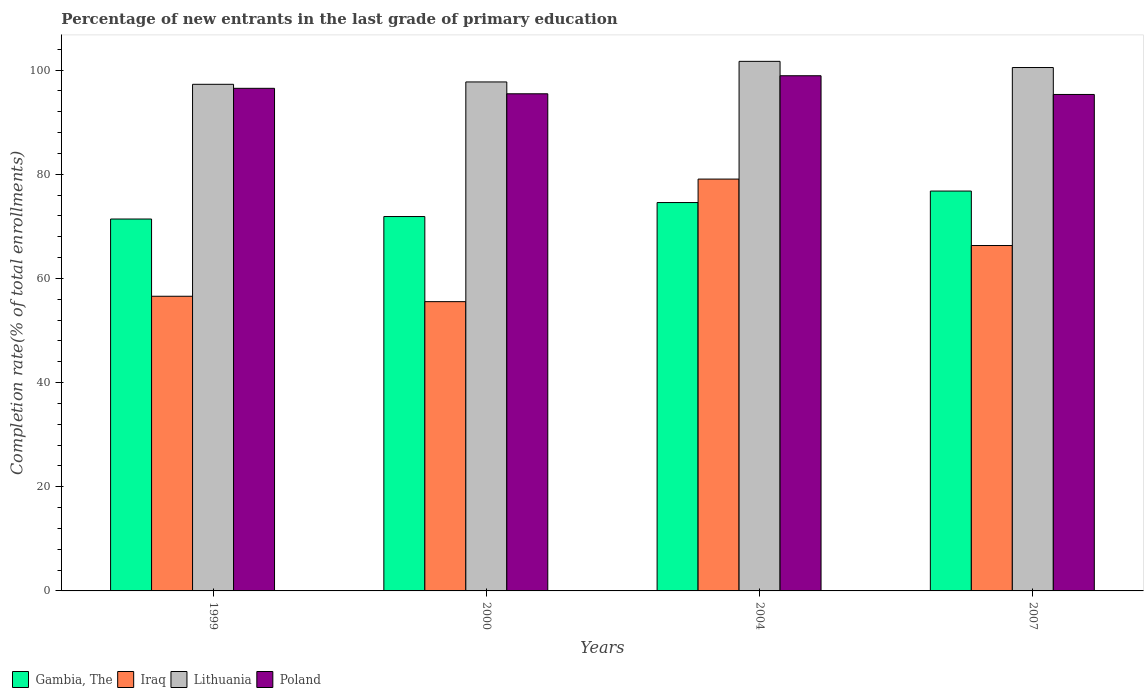How many groups of bars are there?
Make the answer very short. 4. How many bars are there on the 4th tick from the right?
Your response must be concise. 4. What is the label of the 4th group of bars from the left?
Your answer should be very brief. 2007. In how many cases, is the number of bars for a given year not equal to the number of legend labels?
Your answer should be very brief. 0. What is the percentage of new entrants in Gambia, The in 1999?
Give a very brief answer. 71.41. Across all years, what is the maximum percentage of new entrants in Lithuania?
Ensure brevity in your answer.  101.68. Across all years, what is the minimum percentage of new entrants in Poland?
Make the answer very short. 95.32. In which year was the percentage of new entrants in Iraq maximum?
Your answer should be very brief. 2004. In which year was the percentage of new entrants in Poland minimum?
Your answer should be very brief. 2007. What is the total percentage of new entrants in Iraq in the graph?
Your response must be concise. 257.51. What is the difference between the percentage of new entrants in Gambia, The in 1999 and that in 2007?
Offer a very short reply. -5.37. What is the difference between the percentage of new entrants in Gambia, The in 2000 and the percentage of new entrants in Iraq in 1999?
Offer a terse response. 15.31. What is the average percentage of new entrants in Iraq per year?
Give a very brief answer. 64.38. In the year 2004, what is the difference between the percentage of new entrants in Iraq and percentage of new entrants in Poland?
Your answer should be compact. -19.84. What is the ratio of the percentage of new entrants in Lithuania in 2004 to that in 2007?
Offer a terse response. 1.01. Is the difference between the percentage of new entrants in Iraq in 1999 and 2000 greater than the difference between the percentage of new entrants in Poland in 1999 and 2000?
Make the answer very short. No. What is the difference between the highest and the second highest percentage of new entrants in Iraq?
Provide a succinct answer. 12.76. What is the difference between the highest and the lowest percentage of new entrants in Gambia, The?
Make the answer very short. 5.37. What does the 2nd bar from the right in 2004 represents?
Provide a short and direct response. Lithuania. Is it the case that in every year, the sum of the percentage of new entrants in Poland and percentage of new entrants in Iraq is greater than the percentage of new entrants in Gambia, The?
Your response must be concise. Yes. Are the values on the major ticks of Y-axis written in scientific E-notation?
Make the answer very short. No. How many legend labels are there?
Offer a terse response. 4. What is the title of the graph?
Your answer should be very brief. Percentage of new entrants in the last grade of primary education. What is the label or title of the Y-axis?
Offer a terse response. Completion rate(% of total enrollments). What is the Completion rate(% of total enrollments) of Gambia, The in 1999?
Offer a very short reply. 71.41. What is the Completion rate(% of total enrollments) in Iraq in 1999?
Offer a very short reply. 56.58. What is the Completion rate(% of total enrollments) in Lithuania in 1999?
Make the answer very short. 97.27. What is the Completion rate(% of total enrollments) of Poland in 1999?
Offer a terse response. 96.5. What is the Completion rate(% of total enrollments) of Gambia, The in 2000?
Make the answer very short. 71.88. What is the Completion rate(% of total enrollments) in Iraq in 2000?
Give a very brief answer. 55.54. What is the Completion rate(% of total enrollments) in Lithuania in 2000?
Offer a terse response. 97.73. What is the Completion rate(% of total enrollments) in Poland in 2000?
Provide a succinct answer. 95.45. What is the Completion rate(% of total enrollments) of Gambia, The in 2004?
Give a very brief answer. 74.57. What is the Completion rate(% of total enrollments) of Iraq in 2004?
Make the answer very short. 79.07. What is the Completion rate(% of total enrollments) of Lithuania in 2004?
Keep it short and to the point. 101.68. What is the Completion rate(% of total enrollments) in Poland in 2004?
Make the answer very short. 98.92. What is the Completion rate(% of total enrollments) of Gambia, The in 2007?
Your response must be concise. 76.78. What is the Completion rate(% of total enrollments) in Iraq in 2007?
Provide a short and direct response. 66.32. What is the Completion rate(% of total enrollments) in Lithuania in 2007?
Give a very brief answer. 100.5. What is the Completion rate(% of total enrollments) of Poland in 2007?
Your answer should be very brief. 95.32. Across all years, what is the maximum Completion rate(% of total enrollments) in Gambia, The?
Offer a terse response. 76.78. Across all years, what is the maximum Completion rate(% of total enrollments) of Iraq?
Give a very brief answer. 79.07. Across all years, what is the maximum Completion rate(% of total enrollments) in Lithuania?
Ensure brevity in your answer.  101.68. Across all years, what is the maximum Completion rate(% of total enrollments) in Poland?
Offer a terse response. 98.92. Across all years, what is the minimum Completion rate(% of total enrollments) of Gambia, The?
Keep it short and to the point. 71.41. Across all years, what is the minimum Completion rate(% of total enrollments) of Iraq?
Provide a succinct answer. 55.54. Across all years, what is the minimum Completion rate(% of total enrollments) of Lithuania?
Offer a very short reply. 97.27. Across all years, what is the minimum Completion rate(% of total enrollments) in Poland?
Provide a succinct answer. 95.32. What is the total Completion rate(% of total enrollments) in Gambia, The in the graph?
Keep it short and to the point. 294.63. What is the total Completion rate(% of total enrollments) of Iraq in the graph?
Give a very brief answer. 257.51. What is the total Completion rate(% of total enrollments) of Lithuania in the graph?
Your answer should be very brief. 397.17. What is the total Completion rate(% of total enrollments) in Poland in the graph?
Offer a terse response. 386.19. What is the difference between the Completion rate(% of total enrollments) of Gambia, The in 1999 and that in 2000?
Ensure brevity in your answer.  -0.47. What is the difference between the Completion rate(% of total enrollments) of Iraq in 1999 and that in 2000?
Your response must be concise. 1.03. What is the difference between the Completion rate(% of total enrollments) of Lithuania in 1999 and that in 2000?
Your answer should be compact. -0.45. What is the difference between the Completion rate(% of total enrollments) of Poland in 1999 and that in 2000?
Give a very brief answer. 1.05. What is the difference between the Completion rate(% of total enrollments) in Gambia, The in 1999 and that in 2004?
Offer a terse response. -3.16. What is the difference between the Completion rate(% of total enrollments) in Iraq in 1999 and that in 2004?
Provide a short and direct response. -22.5. What is the difference between the Completion rate(% of total enrollments) in Lithuania in 1999 and that in 2004?
Your answer should be very brief. -4.41. What is the difference between the Completion rate(% of total enrollments) of Poland in 1999 and that in 2004?
Ensure brevity in your answer.  -2.42. What is the difference between the Completion rate(% of total enrollments) in Gambia, The in 1999 and that in 2007?
Make the answer very short. -5.37. What is the difference between the Completion rate(% of total enrollments) in Iraq in 1999 and that in 2007?
Your answer should be compact. -9.74. What is the difference between the Completion rate(% of total enrollments) of Lithuania in 1999 and that in 2007?
Your answer should be very brief. -3.22. What is the difference between the Completion rate(% of total enrollments) of Poland in 1999 and that in 2007?
Make the answer very short. 1.18. What is the difference between the Completion rate(% of total enrollments) of Gambia, The in 2000 and that in 2004?
Provide a short and direct response. -2.69. What is the difference between the Completion rate(% of total enrollments) in Iraq in 2000 and that in 2004?
Provide a short and direct response. -23.53. What is the difference between the Completion rate(% of total enrollments) in Lithuania in 2000 and that in 2004?
Keep it short and to the point. -3.95. What is the difference between the Completion rate(% of total enrollments) in Poland in 2000 and that in 2004?
Ensure brevity in your answer.  -3.47. What is the difference between the Completion rate(% of total enrollments) of Gambia, The in 2000 and that in 2007?
Ensure brevity in your answer.  -4.89. What is the difference between the Completion rate(% of total enrollments) in Iraq in 2000 and that in 2007?
Provide a short and direct response. -10.77. What is the difference between the Completion rate(% of total enrollments) in Lithuania in 2000 and that in 2007?
Give a very brief answer. -2.77. What is the difference between the Completion rate(% of total enrollments) in Poland in 2000 and that in 2007?
Your response must be concise. 0.13. What is the difference between the Completion rate(% of total enrollments) in Gambia, The in 2004 and that in 2007?
Keep it short and to the point. -2.21. What is the difference between the Completion rate(% of total enrollments) of Iraq in 2004 and that in 2007?
Your answer should be very brief. 12.76. What is the difference between the Completion rate(% of total enrollments) in Lithuania in 2004 and that in 2007?
Offer a very short reply. 1.18. What is the difference between the Completion rate(% of total enrollments) of Poland in 2004 and that in 2007?
Your answer should be compact. 3.6. What is the difference between the Completion rate(% of total enrollments) in Gambia, The in 1999 and the Completion rate(% of total enrollments) in Iraq in 2000?
Your answer should be very brief. 15.86. What is the difference between the Completion rate(% of total enrollments) in Gambia, The in 1999 and the Completion rate(% of total enrollments) in Lithuania in 2000?
Ensure brevity in your answer.  -26.32. What is the difference between the Completion rate(% of total enrollments) of Gambia, The in 1999 and the Completion rate(% of total enrollments) of Poland in 2000?
Your response must be concise. -24.04. What is the difference between the Completion rate(% of total enrollments) of Iraq in 1999 and the Completion rate(% of total enrollments) of Lithuania in 2000?
Your answer should be very brief. -41.15. What is the difference between the Completion rate(% of total enrollments) of Iraq in 1999 and the Completion rate(% of total enrollments) of Poland in 2000?
Your answer should be very brief. -38.88. What is the difference between the Completion rate(% of total enrollments) in Lithuania in 1999 and the Completion rate(% of total enrollments) in Poland in 2000?
Your response must be concise. 1.82. What is the difference between the Completion rate(% of total enrollments) of Gambia, The in 1999 and the Completion rate(% of total enrollments) of Iraq in 2004?
Keep it short and to the point. -7.67. What is the difference between the Completion rate(% of total enrollments) of Gambia, The in 1999 and the Completion rate(% of total enrollments) of Lithuania in 2004?
Ensure brevity in your answer.  -30.27. What is the difference between the Completion rate(% of total enrollments) of Gambia, The in 1999 and the Completion rate(% of total enrollments) of Poland in 2004?
Keep it short and to the point. -27.51. What is the difference between the Completion rate(% of total enrollments) in Iraq in 1999 and the Completion rate(% of total enrollments) in Lithuania in 2004?
Give a very brief answer. -45.1. What is the difference between the Completion rate(% of total enrollments) in Iraq in 1999 and the Completion rate(% of total enrollments) in Poland in 2004?
Offer a terse response. -42.34. What is the difference between the Completion rate(% of total enrollments) in Lithuania in 1999 and the Completion rate(% of total enrollments) in Poland in 2004?
Keep it short and to the point. -1.65. What is the difference between the Completion rate(% of total enrollments) in Gambia, The in 1999 and the Completion rate(% of total enrollments) in Iraq in 2007?
Your answer should be very brief. 5.09. What is the difference between the Completion rate(% of total enrollments) of Gambia, The in 1999 and the Completion rate(% of total enrollments) of Lithuania in 2007?
Offer a terse response. -29.09. What is the difference between the Completion rate(% of total enrollments) in Gambia, The in 1999 and the Completion rate(% of total enrollments) in Poland in 2007?
Make the answer very short. -23.91. What is the difference between the Completion rate(% of total enrollments) of Iraq in 1999 and the Completion rate(% of total enrollments) of Lithuania in 2007?
Provide a succinct answer. -43.92. What is the difference between the Completion rate(% of total enrollments) of Iraq in 1999 and the Completion rate(% of total enrollments) of Poland in 2007?
Give a very brief answer. -38.75. What is the difference between the Completion rate(% of total enrollments) of Lithuania in 1999 and the Completion rate(% of total enrollments) of Poland in 2007?
Offer a very short reply. 1.95. What is the difference between the Completion rate(% of total enrollments) of Gambia, The in 2000 and the Completion rate(% of total enrollments) of Iraq in 2004?
Give a very brief answer. -7.19. What is the difference between the Completion rate(% of total enrollments) in Gambia, The in 2000 and the Completion rate(% of total enrollments) in Lithuania in 2004?
Offer a very short reply. -29.8. What is the difference between the Completion rate(% of total enrollments) in Gambia, The in 2000 and the Completion rate(% of total enrollments) in Poland in 2004?
Your answer should be very brief. -27.04. What is the difference between the Completion rate(% of total enrollments) of Iraq in 2000 and the Completion rate(% of total enrollments) of Lithuania in 2004?
Provide a short and direct response. -46.14. What is the difference between the Completion rate(% of total enrollments) in Iraq in 2000 and the Completion rate(% of total enrollments) in Poland in 2004?
Keep it short and to the point. -43.38. What is the difference between the Completion rate(% of total enrollments) of Lithuania in 2000 and the Completion rate(% of total enrollments) of Poland in 2004?
Keep it short and to the point. -1.19. What is the difference between the Completion rate(% of total enrollments) of Gambia, The in 2000 and the Completion rate(% of total enrollments) of Iraq in 2007?
Your answer should be very brief. 5.56. What is the difference between the Completion rate(% of total enrollments) of Gambia, The in 2000 and the Completion rate(% of total enrollments) of Lithuania in 2007?
Keep it short and to the point. -28.61. What is the difference between the Completion rate(% of total enrollments) in Gambia, The in 2000 and the Completion rate(% of total enrollments) in Poland in 2007?
Ensure brevity in your answer.  -23.44. What is the difference between the Completion rate(% of total enrollments) in Iraq in 2000 and the Completion rate(% of total enrollments) in Lithuania in 2007?
Keep it short and to the point. -44.95. What is the difference between the Completion rate(% of total enrollments) of Iraq in 2000 and the Completion rate(% of total enrollments) of Poland in 2007?
Provide a succinct answer. -39.78. What is the difference between the Completion rate(% of total enrollments) of Lithuania in 2000 and the Completion rate(% of total enrollments) of Poland in 2007?
Keep it short and to the point. 2.4. What is the difference between the Completion rate(% of total enrollments) in Gambia, The in 2004 and the Completion rate(% of total enrollments) in Iraq in 2007?
Your answer should be compact. 8.25. What is the difference between the Completion rate(% of total enrollments) in Gambia, The in 2004 and the Completion rate(% of total enrollments) in Lithuania in 2007?
Keep it short and to the point. -25.93. What is the difference between the Completion rate(% of total enrollments) in Gambia, The in 2004 and the Completion rate(% of total enrollments) in Poland in 2007?
Offer a terse response. -20.75. What is the difference between the Completion rate(% of total enrollments) of Iraq in 2004 and the Completion rate(% of total enrollments) of Lithuania in 2007?
Keep it short and to the point. -21.42. What is the difference between the Completion rate(% of total enrollments) in Iraq in 2004 and the Completion rate(% of total enrollments) in Poland in 2007?
Keep it short and to the point. -16.25. What is the difference between the Completion rate(% of total enrollments) of Lithuania in 2004 and the Completion rate(% of total enrollments) of Poland in 2007?
Provide a succinct answer. 6.36. What is the average Completion rate(% of total enrollments) in Gambia, The per year?
Your response must be concise. 73.66. What is the average Completion rate(% of total enrollments) of Iraq per year?
Offer a terse response. 64.38. What is the average Completion rate(% of total enrollments) of Lithuania per year?
Provide a short and direct response. 99.29. What is the average Completion rate(% of total enrollments) of Poland per year?
Your answer should be very brief. 96.55. In the year 1999, what is the difference between the Completion rate(% of total enrollments) in Gambia, The and Completion rate(% of total enrollments) in Iraq?
Your response must be concise. 14.83. In the year 1999, what is the difference between the Completion rate(% of total enrollments) in Gambia, The and Completion rate(% of total enrollments) in Lithuania?
Ensure brevity in your answer.  -25.87. In the year 1999, what is the difference between the Completion rate(% of total enrollments) in Gambia, The and Completion rate(% of total enrollments) in Poland?
Provide a succinct answer. -25.09. In the year 1999, what is the difference between the Completion rate(% of total enrollments) in Iraq and Completion rate(% of total enrollments) in Lithuania?
Make the answer very short. -40.7. In the year 1999, what is the difference between the Completion rate(% of total enrollments) in Iraq and Completion rate(% of total enrollments) in Poland?
Ensure brevity in your answer.  -39.92. In the year 1999, what is the difference between the Completion rate(% of total enrollments) in Lithuania and Completion rate(% of total enrollments) in Poland?
Your answer should be compact. 0.77. In the year 2000, what is the difference between the Completion rate(% of total enrollments) in Gambia, The and Completion rate(% of total enrollments) in Iraq?
Make the answer very short. 16.34. In the year 2000, what is the difference between the Completion rate(% of total enrollments) in Gambia, The and Completion rate(% of total enrollments) in Lithuania?
Make the answer very short. -25.84. In the year 2000, what is the difference between the Completion rate(% of total enrollments) in Gambia, The and Completion rate(% of total enrollments) in Poland?
Offer a terse response. -23.57. In the year 2000, what is the difference between the Completion rate(% of total enrollments) of Iraq and Completion rate(% of total enrollments) of Lithuania?
Keep it short and to the point. -42.18. In the year 2000, what is the difference between the Completion rate(% of total enrollments) of Iraq and Completion rate(% of total enrollments) of Poland?
Ensure brevity in your answer.  -39.91. In the year 2000, what is the difference between the Completion rate(% of total enrollments) in Lithuania and Completion rate(% of total enrollments) in Poland?
Your answer should be very brief. 2.27. In the year 2004, what is the difference between the Completion rate(% of total enrollments) of Gambia, The and Completion rate(% of total enrollments) of Iraq?
Offer a terse response. -4.51. In the year 2004, what is the difference between the Completion rate(% of total enrollments) in Gambia, The and Completion rate(% of total enrollments) in Lithuania?
Provide a short and direct response. -27.11. In the year 2004, what is the difference between the Completion rate(% of total enrollments) in Gambia, The and Completion rate(% of total enrollments) in Poland?
Give a very brief answer. -24.35. In the year 2004, what is the difference between the Completion rate(% of total enrollments) of Iraq and Completion rate(% of total enrollments) of Lithuania?
Offer a terse response. -22.61. In the year 2004, what is the difference between the Completion rate(% of total enrollments) in Iraq and Completion rate(% of total enrollments) in Poland?
Your answer should be very brief. -19.84. In the year 2004, what is the difference between the Completion rate(% of total enrollments) of Lithuania and Completion rate(% of total enrollments) of Poland?
Your answer should be very brief. 2.76. In the year 2007, what is the difference between the Completion rate(% of total enrollments) of Gambia, The and Completion rate(% of total enrollments) of Iraq?
Offer a very short reply. 10.46. In the year 2007, what is the difference between the Completion rate(% of total enrollments) in Gambia, The and Completion rate(% of total enrollments) in Lithuania?
Your response must be concise. -23.72. In the year 2007, what is the difference between the Completion rate(% of total enrollments) in Gambia, The and Completion rate(% of total enrollments) in Poland?
Give a very brief answer. -18.55. In the year 2007, what is the difference between the Completion rate(% of total enrollments) in Iraq and Completion rate(% of total enrollments) in Lithuania?
Your answer should be compact. -34.18. In the year 2007, what is the difference between the Completion rate(% of total enrollments) in Iraq and Completion rate(% of total enrollments) in Poland?
Offer a terse response. -29.01. In the year 2007, what is the difference between the Completion rate(% of total enrollments) in Lithuania and Completion rate(% of total enrollments) in Poland?
Provide a short and direct response. 5.17. What is the ratio of the Completion rate(% of total enrollments) of Gambia, The in 1999 to that in 2000?
Give a very brief answer. 0.99. What is the ratio of the Completion rate(% of total enrollments) in Iraq in 1999 to that in 2000?
Offer a very short reply. 1.02. What is the ratio of the Completion rate(% of total enrollments) in Poland in 1999 to that in 2000?
Offer a terse response. 1.01. What is the ratio of the Completion rate(% of total enrollments) in Gambia, The in 1999 to that in 2004?
Ensure brevity in your answer.  0.96. What is the ratio of the Completion rate(% of total enrollments) of Iraq in 1999 to that in 2004?
Your answer should be compact. 0.72. What is the ratio of the Completion rate(% of total enrollments) of Lithuania in 1999 to that in 2004?
Ensure brevity in your answer.  0.96. What is the ratio of the Completion rate(% of total enrollments) in Poland in 1999 to that in 2004?
Your answer should be very brief. 0.98. What is the ratio of the Completion rate(% of total enrollments) of Gambia, The in 1999 to that in 2007?
Your answer should be very brief. 0.93. What is the ratio of the Completion rate(% of total enrollments) of Iraq in 1999 to that in 2007?
Your answer should be very brief. 0.85. What is the ratio of the Completion rate(% of total enrollments) in Lithuania in 1999 to that in 2007?
Your answer should be very brief. 0.97. What is the ratio of the Completion rate(% of total enrollments) of Poland in 1999 to that in 2007?
Your answer should be compact. 1.01. What is the ratio of the Completion rate(% of total enrollments) in Iraq in 2000 to that in 2004?
Give a very brief answer. 0.7. What is the ratio of the Completion rate(% of total enrollments) in Lithuania in 2000 to that in 2004?
Your answer should be compact. 0.96. What is the ratio of the Completion rate(% of total enrollments) in Poland in 2000 to that in 2004?
Give a very brief answer. 0.96. What is the ratio of the Completion rate(% of total enrollments) of Gambia, The in 2000 to that in 2007?
Provide a succinct answer. 0.94. What is the ratio of the Completion rate(% of total enrollments) in Iraq in 2000 to that in 2007?
Give a very brief answer. 0.84. What is the ratio of the Completion rate(% of total enrollments) in Lithuania in 2000 to that in 2007?
Provide a short and direct response. 0.97. What is the ratio of the Completion rate(% of total enrollments) of Poland in 2000 to that in 2007?
Make the answer very short. 1. What is the ratio of the Completion rate(% of total enrollments) in Gambia, The in 2004 to that in 2007?
Offer a terse response. 0.97. What is the ratio of the Completion rate(% of total enrollments) of Iraq in 2004 to that in 2007?
Ensure brevity in your answer.  1.19. What is the ratio of the Completion rate(% of total enrollments) in Lithuania in 2004 to that in 2007?
Your answer should be compact. 1.01. What is the ratio of the Completion rate(% of total enrollments) of Poland in 2004 to that in 2007?
Offer a terse response. 1.04. What is the difference between the highest and the second highest Completion rate(% of total enrollments) in Gambia, The?
Give a very brief answer. 2.21. What is the difference between the highest and the second highest Completion rate(% of total enrollments) in Iraq?
Your answer should be very brief. 12.76. What is the difference between the highest and the second highest Completion rate(% of total enrollments) of Lithuania?
Your answer should be compact. 1.18. What is the difference between the highest and the second highest Completion rate(% of total enrollments) of Poland?
Offer a terse response. 2.42. What is the difference between the highest and the lowest Completion rate(% of total enrollments) in Gambia, The?
Keep it short and to the point. 5.37. What is the difference between the highest and the lowest Completion rate(% of total enrollments) of Iraq?
Give a very brief answer. 23.53. What is the difference between the highest and the lowest Completion rate(% of total enrollments) of Lithuania?
Keep it short and to the point. 4.41. What is the difference between the highest and the lowest Completion rate(% of total enrollments) in Poland?
Provide a short and direct response. 3.6. 